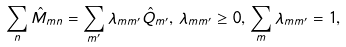<formula> <loc_0><loc_0><loc_500><loc_500>\sum _ { n } \hat { M } _ { m n } = \sum _ { m ^ { \prime } } \lambda _ { m m ^ { \prime } } \hat { Q } _ { m ^ { \prime } } , \, \lambda _ { m m ^ { \prime } } \geq 0 , \, \sum _ { m } \lambda _ { m m ^ { \prime } } = 1 ,</formula> 